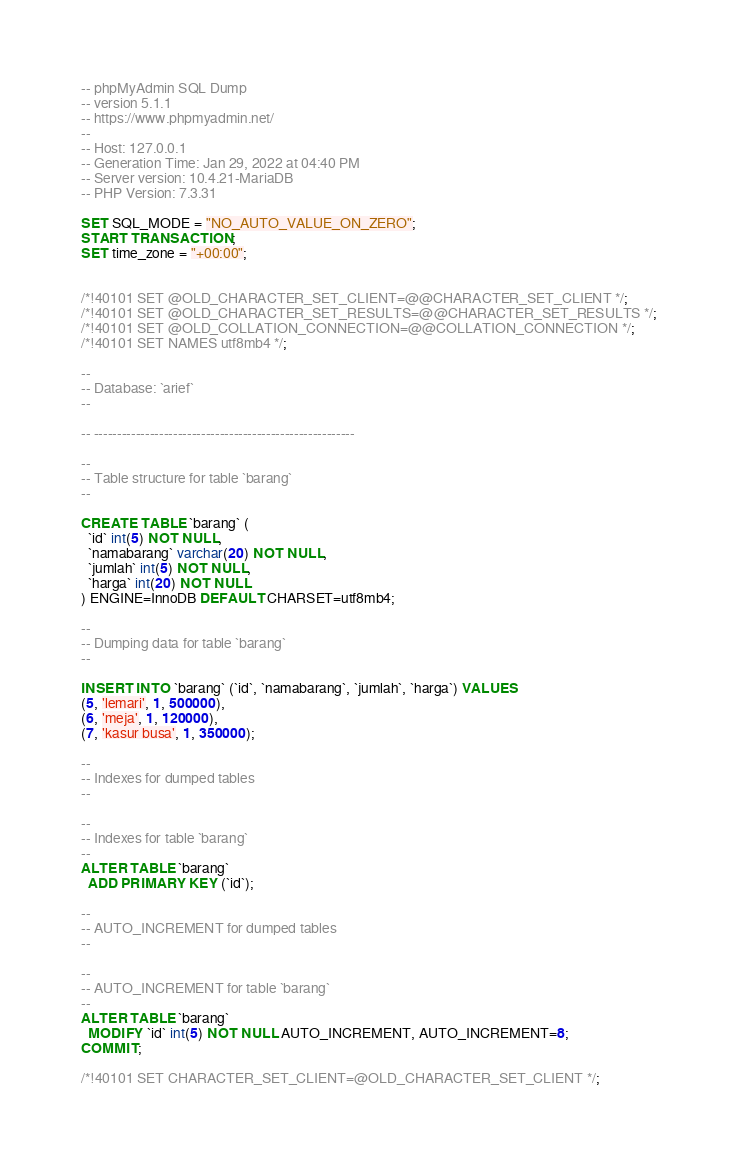Convert code to text. <code><loc_0><loc_0><loc_500><loc_500><_SQL_>-- phpMyAdmin SQL Dump
-- version 5.1.1
-- https://www.phpmyadmin.net/
--
-- Host: 127.0.0.1
-- Generation Time: Jan 29, 2022 at 04:40 PM
-- Server version: 10.4.21-MariaDB
-- PHP Version: 7.3.31

SET SQL_MODE = "NO_AUTO_VALUE_ON_ZERO";
START TRANSACTION;
SET time_zone = "+00:00";


/*!40101 SET @OLD_CHARACTER_SET_CLIENT=@@CHARACTER_SET_CLIENT */;
/*!40101 SET @OLD_CHARACTER_SET_RESULTS=@@CHARACTER_SET_RESULTS */;
/*!40101 SET @OLD_COLLATION_CONNECTION=@@COLLATION_CONNECTION */;
/*!40101 SET NAMES utf8mb4 */;

--
-- Database: `arief`
--

-- --------------------------------------------------------

--
-- Table structure for table `barang`
--

CREATE TABLE `barang` (
  `id` int(5) NOT NULL,
  `namabarang` varchar(20) NOT NULL,
  `jumlah` int(5) NOT NULL,
  `harga` int(20) NOT NULL
) ENGINE=InnoDB DEFAULT CHARSET=utf8mb4;

--
-- Dumping data for table `barang`
--

INSERT INTO `barang` (`id`, `namabarang`, `jumlah`, `harga`) VALUES
(5, 'lemari', 1, 500000),
(6, 'meja', 1, 120000),
(7, 'kasur busa', 1, 350000);

--
-- Indexes for dumped tables
--

--
-- Indexes for table `barang`
--
ALTER TABLE `barang`
  ADD PRIMARY KEY (`id`);

--
-- AUTO_INCREMENT for dumped tables
--

--
-- AUTO_INCREMENT for table `barang`
--
ALTER TABLE `barang`
  MODIFY `id` int(5) NOT NULL AUTO_INCREMENT, AUTO_INCREMENT=8;
COMMIT;

/*!40101 SET CHARACTER_SET_CLIENT=@OLD_CHARACTER_SET_CLIENT */;</code> 